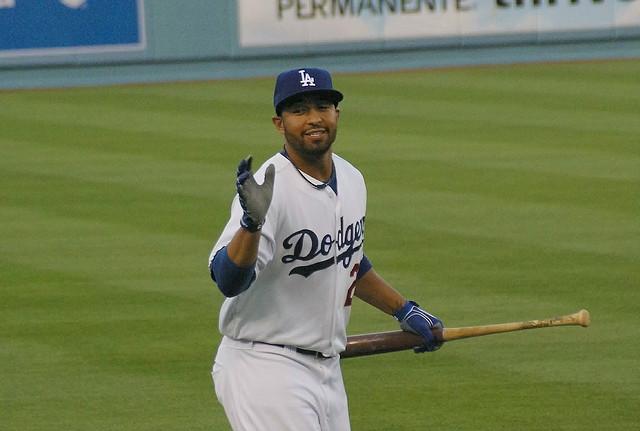What is the man wearing on his head?
Be succinct. Hat. What is the hat called that the man is wearing?
Be succinct. Cap. What team does this man play for?
Give a very brief answer. Dodgers. What professional team is playing?
Be succinct. Dodgers. Does the man have a beard?
Short answer required. Yes. What country is he likely from?
Short answer required. United states. What baseball team does he plays?
Short answer required. Dodgers. What sport is being played?
Concise answer only. Baseball. What team does the batter play for?
Quick response, please. Dodgers. What hand is holding the bat?
Short answer required. Left. What does the man have in hand?
Write a very short answer. Bat. Is this Team based in Los Angeles?
Answer briefly. Yes. What is the name of this baseball player?
Give a very brief answer. Dodgers. 